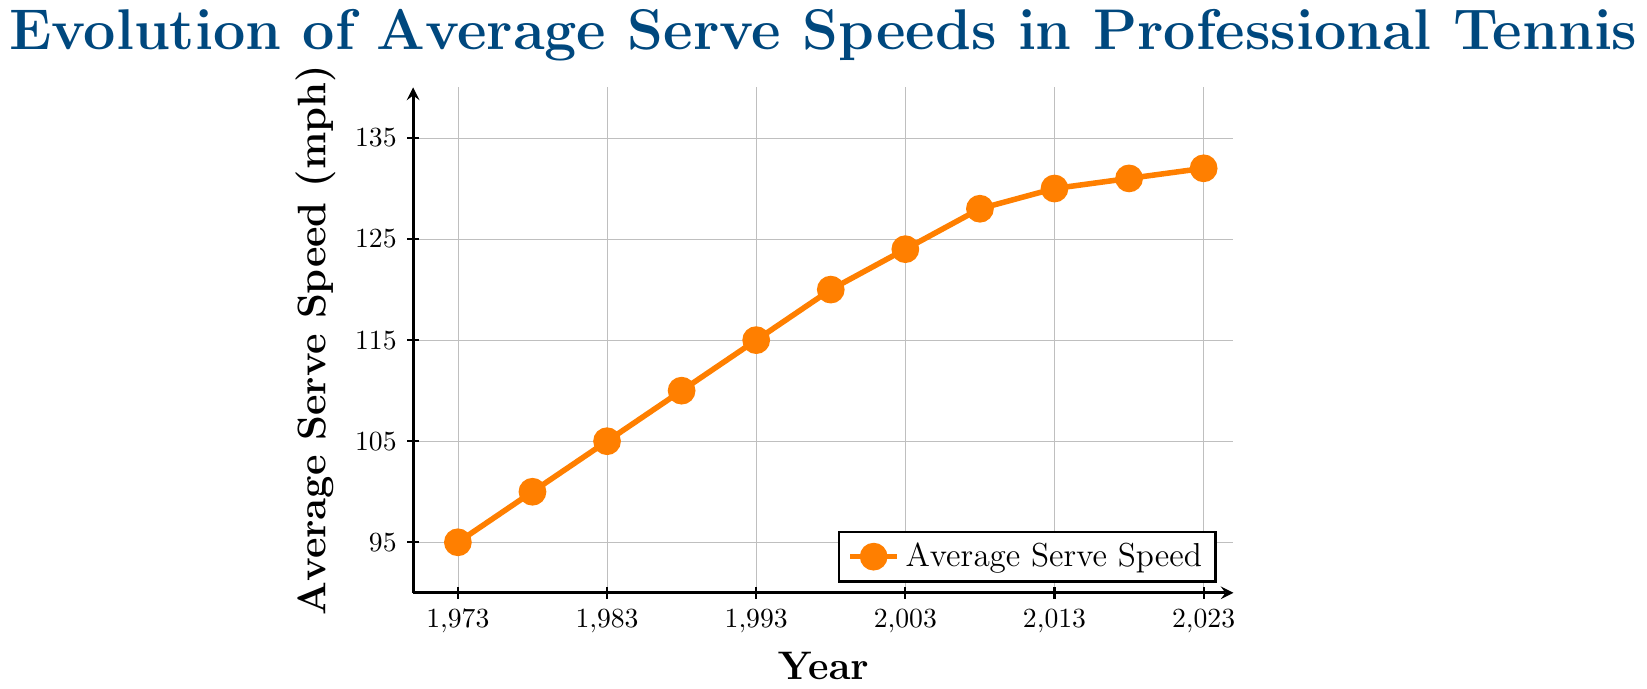What is the average serve speed in 1983? The figure shows the average serve speed for each year as a data point. Look for the year 1983 and find its corresponding value.
Answer: 105 mph Which year had the highest average serve speed? To find the highest average serve speed, look at all the data points and identify the year with the highest vertical placement on the y-axis.
Answer: 2023 What is the difference in average serve speed between 1973 and 2023? Find the average serve speeds for the years 1973 and 2023 from the figure, then subtract the former from the latter. Value in 2023: 132 mph, Value in 1973: 95 mph, Difference: 132 - 95
Answer: 37 mph How much did the average serve speed increase from 1988 to 1993? Find the average serve speeds for the years 1988 and 1993 from the figure, then subtract the value in 1988 from the value in 1993. Value in 1993: 115 mph, Value in 1988: 110 mph, Increase: 115 - 110
Answer: 5 mph What is the trend in average serve speeds from 2008 to 2018? Look at the data points from 2008 to 2018 and observe whether they are increasing, decreasing, or stable. Values: 2008: 128 mph, 2013: 130 mph, 2018: 131 mph. The trend is increasing.
Answer: Increasing Which five-year period saw the highest increase in average serve speeds? Compare the increases in average serve speeds for each consecutive five-year period by subtracting the earlier value from the later value and identifying the largest increase. The increases are: 1973-1978: 5 mph, 1978-1983: 5 mph, 1983-1988: 5 mph, 1988-1993: 5 mph, 1993-1998: 5 mph, 1998-2003: 4 mph, 2003-2008: 4 mph, 2008-2013: 2 mph, 2013-2018: 1 mph, 2018-2023: 1 mph.
Answer: 1973-1978 What is the average serve speed over the 50 years shown? Add up all the average serve speeds for each year and then divide by the number of data points (11). Sum: 95 + 100 + 105 + 110 + 115 + 120 + 124 + 128 + 130 + 131 + 132 = 1290, Average: 1290 / 11
Answer: 117.3 mph Compare the average serve speeds in 1978 and 2003. Which year had a higher serve speed, and by how much? Find the values for the years 1978 and 2003, then subtract the earlier value from the later value to determine the difference. Value in 2003: 124 mph, Value in 1978: 100 mph, Difference: 124 - 100
Answer: 2003 by 24 mph How did the serve speed change from 2018 to 2023? Find the values for 2018 and 2023 and subtract the former from the latter. Value in 2023: 132 mph, Value in 2018: 131 mph, Difference: 132 - 131
Answer: Increased by 1 mph 